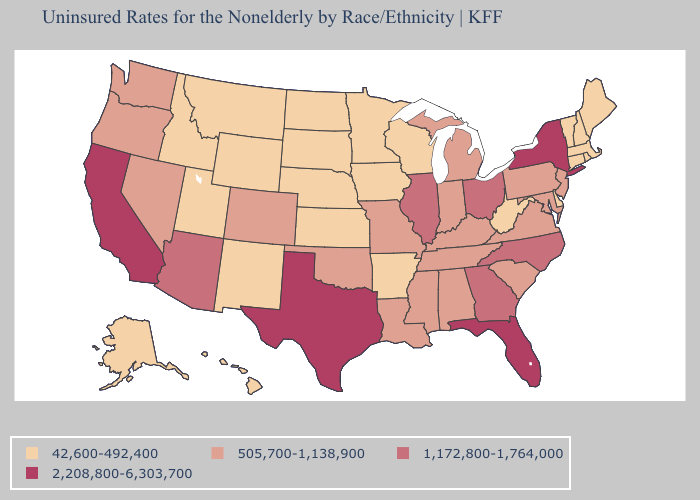How many symbols are there in the legend?
Short answer required. 4. What is the lowest value in the Northeast?
Short answer required. 42,600-492,400. Does Florida have the highest value in the USA?
Answer briefly. Yes. What is the lowest value in the USA?
Give a very brief answer. 42,600-492,400. How many symbols are there in the legend?
Concise answer only. 4. Does North Dakota have the highest value in the USA?
Give a very brief answer. No. Name the states that have a value in the range 1,172,800-1,764,000?
Concise answer only. Arizona, Georgia, Illinois, North Carolina, Ohio. What is the lowest value in the USA?
Quick response, please. 42,600-492,400. Name the states that have a value in the range 42,600-492,400?
Write a very short answer. Alaska, Arkansas, Connecticut, Delaware, Hawaii, Idaho, Iowa, Kansas, Maine, Massachusetts, Minnesota, Montana, Nebraska, New Hampshire, New Mexico, North Dakota, Rhode Island, South Dakota, Utah, Vermont, West Virginia, Wisconsin, Wyoming. What is the value of Kansas?
Give a very brief answer. 42,600-492,400. What is the value of Alabama?
Short answer required. 505,700-1,138,900. What is the value of South Dakota?
Be succinct. 42,600-492,400. Name the states that have a value in the range 505,700-1,138,900?
Quick response, please. Alabama, Colorado, Indiana, Kentucky, Louisiana, Maryland, Michigan, Mississippi, Missouri, Nevada, New Jersey, Oklahoma, Oregon, Pennsylvania, South Carolina, Tennessee, Virginia, Washington. Which states have the highest value in the USA?
Give a very brief answer. California, Florida, New York, Texas. What is the lowest value in the South?
Be succinct. 42,600-492,400. 